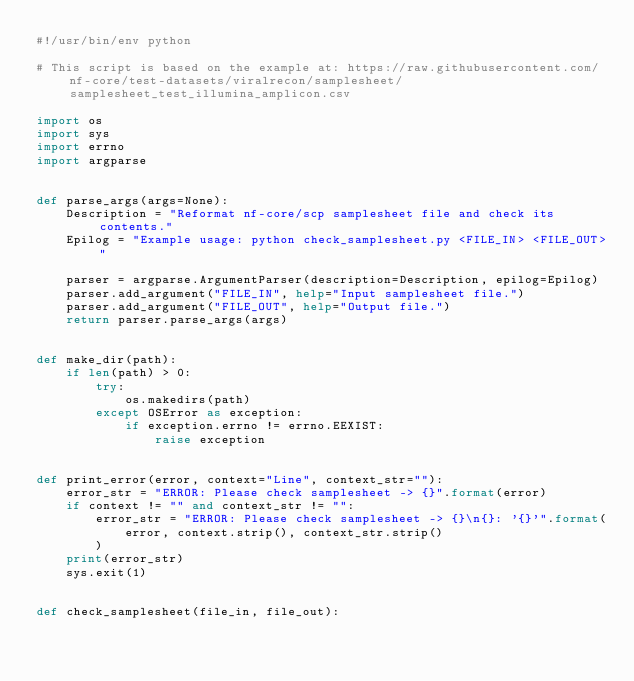Convert code to text. <code><loc_0><loc_0><loc_500><loc_500><_Python_>#!/usr/bin/env python

# This script is based on the example at: https://raw.githubusercontent.com/nf-core/test-datasets/viralrecon/samplesheet/samplesheet_test_illumina_amplicon.csv

import os
import sys
import errno
import argparse


def parse_args(args=None):
    Description = "Reformat nf-core/scp samplesheet file and check its contents."
    Epilog = "Example usage: python check_samplesheet.py <FILE_IN> <FILE_OUT>"

    parser = argparse.ArgumentParser(description=Description, epilog=Epilog)
    parser.add_argument("FILE_IN", help="Input samplesheet file.")
    parser.add_argument("FILE_OUT", help="Output file.")
    return parser.parse_args(args)


def make_dir(path):
    if len(path) > 0:
        try:
            os.makedirs(path)
        except OSError as exception:
            if exception.errno != errno.EEXIST:
                raise exception


def print_error(error, context="Line", context_str=""):
    error_str = "ERROR: Please check samplesheet -> {}".format(error)
    if context != "" and context_str != "":
        error_str = "ERROR: Please check samplesheet -> {}\n{}: '{}'".format(
            error, context.strip(), context_str.strip()
        )
    print(error_str)
    sys.exit(1)


def check_samplesheet(file_in, file_out):</code> 